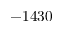<formula> <loc_0><loc_0><loc_500><loc_500>- 1 4 3 0</formula> 